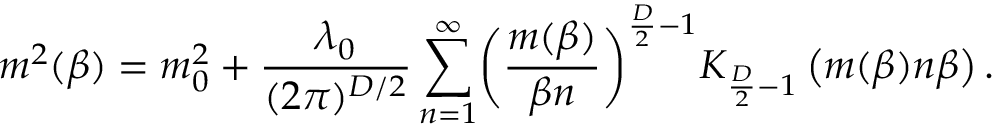<formula> <loc_0><loc_0><loc_500><loc_500>\ m ^ { 2 } ( \beta ) = m _ { 0 } ^ { 2 } + \frac { \lambda _ { 0 } } { ( 2 \pi ) ^ { D / 2 } } \sum _ { n = 1 } ^ { \infty } \left ( \frac { m ( \beta ) } { \beta n } \right ) ^ { \frac { D } { 2 } - 1 } K _ { \frac { D } { 2 } - 1 } \left ( m ( \beta ) n \beta \right ) .</formula> 